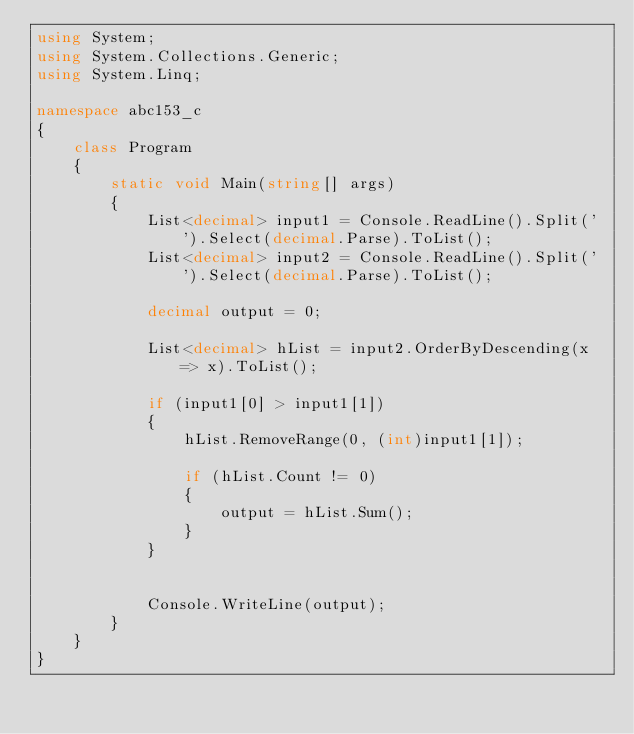Convert code to text. <code><loc_0><loc_0><loc_500><loc_500><_C#_>using System;
using System.Collections.Generic;
using System.Linq;

namespace abc153_c
{
    class Program
    {
        static void Main(string[] args)
        {
            List<decimal> input1 = Console.ReadLine().Split(' ').Select(decimal.Parse).ToList();
            List<decimal> input2 = Console.ReadLine().Split(' ').Select(decimal.Parse).ToList();

            decimal output = 0;

            List<decimal> hList = input2.OrderByDescending(x => x).ToList();

            if (input1[0] > input1[1])
            {
                hList.RemoveRange(0, (int)input1[1]);

                if (hList.Count != 0)
                {
                    output = hList.Sum();
                }
            }


            Console.WriteLine(output);
        }
    }
}
</code> 